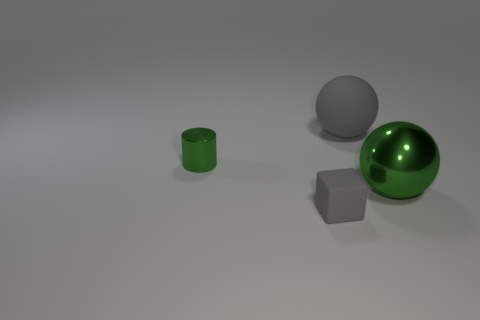Add 4 large metal things. How many objects exist? 8 Subtract all blocks. How many objects are left? 3 Add 2 big gray things. How many big gray things exist? 3 Subtract 0 yellow spheres. How many objects are left? 4 Subtract all small green metallic objects. Subtract all tiny rubber cubes. How many objects are left? 2 Add 3 large spheres. How many large spheres are left? 5 